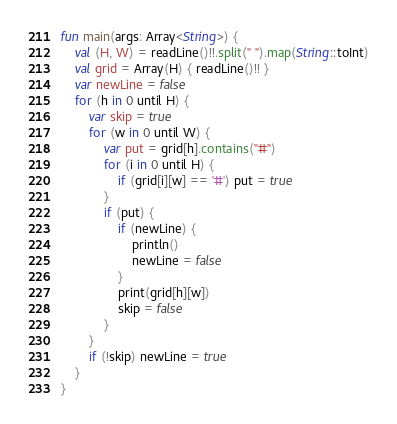Convert code to text. <code><loc_0><loc_0><loc_500><loc_500><_Kotlin_>fun main(args: Array<String>) {
    val (H, W) = readLine()!!.split(" ").map(String::toInt)
    val grid = Array(H) { readLine()!! }
    var newLine = false
    for (h in 0 until H) {
        var skip = true
        for (w in 0 until W) {
            var put = grid[h].contains("#")
            for (i in 0 until H) {
                if (grid[i][w] == '#') put = true
            }
            if (put) {
                if (newLine) {
                    println()
                    newLine = false
                }
                print(grid[h][w])
                skip = false
            }
        }
        if (!skip) newLine = true
    }
}</code> 